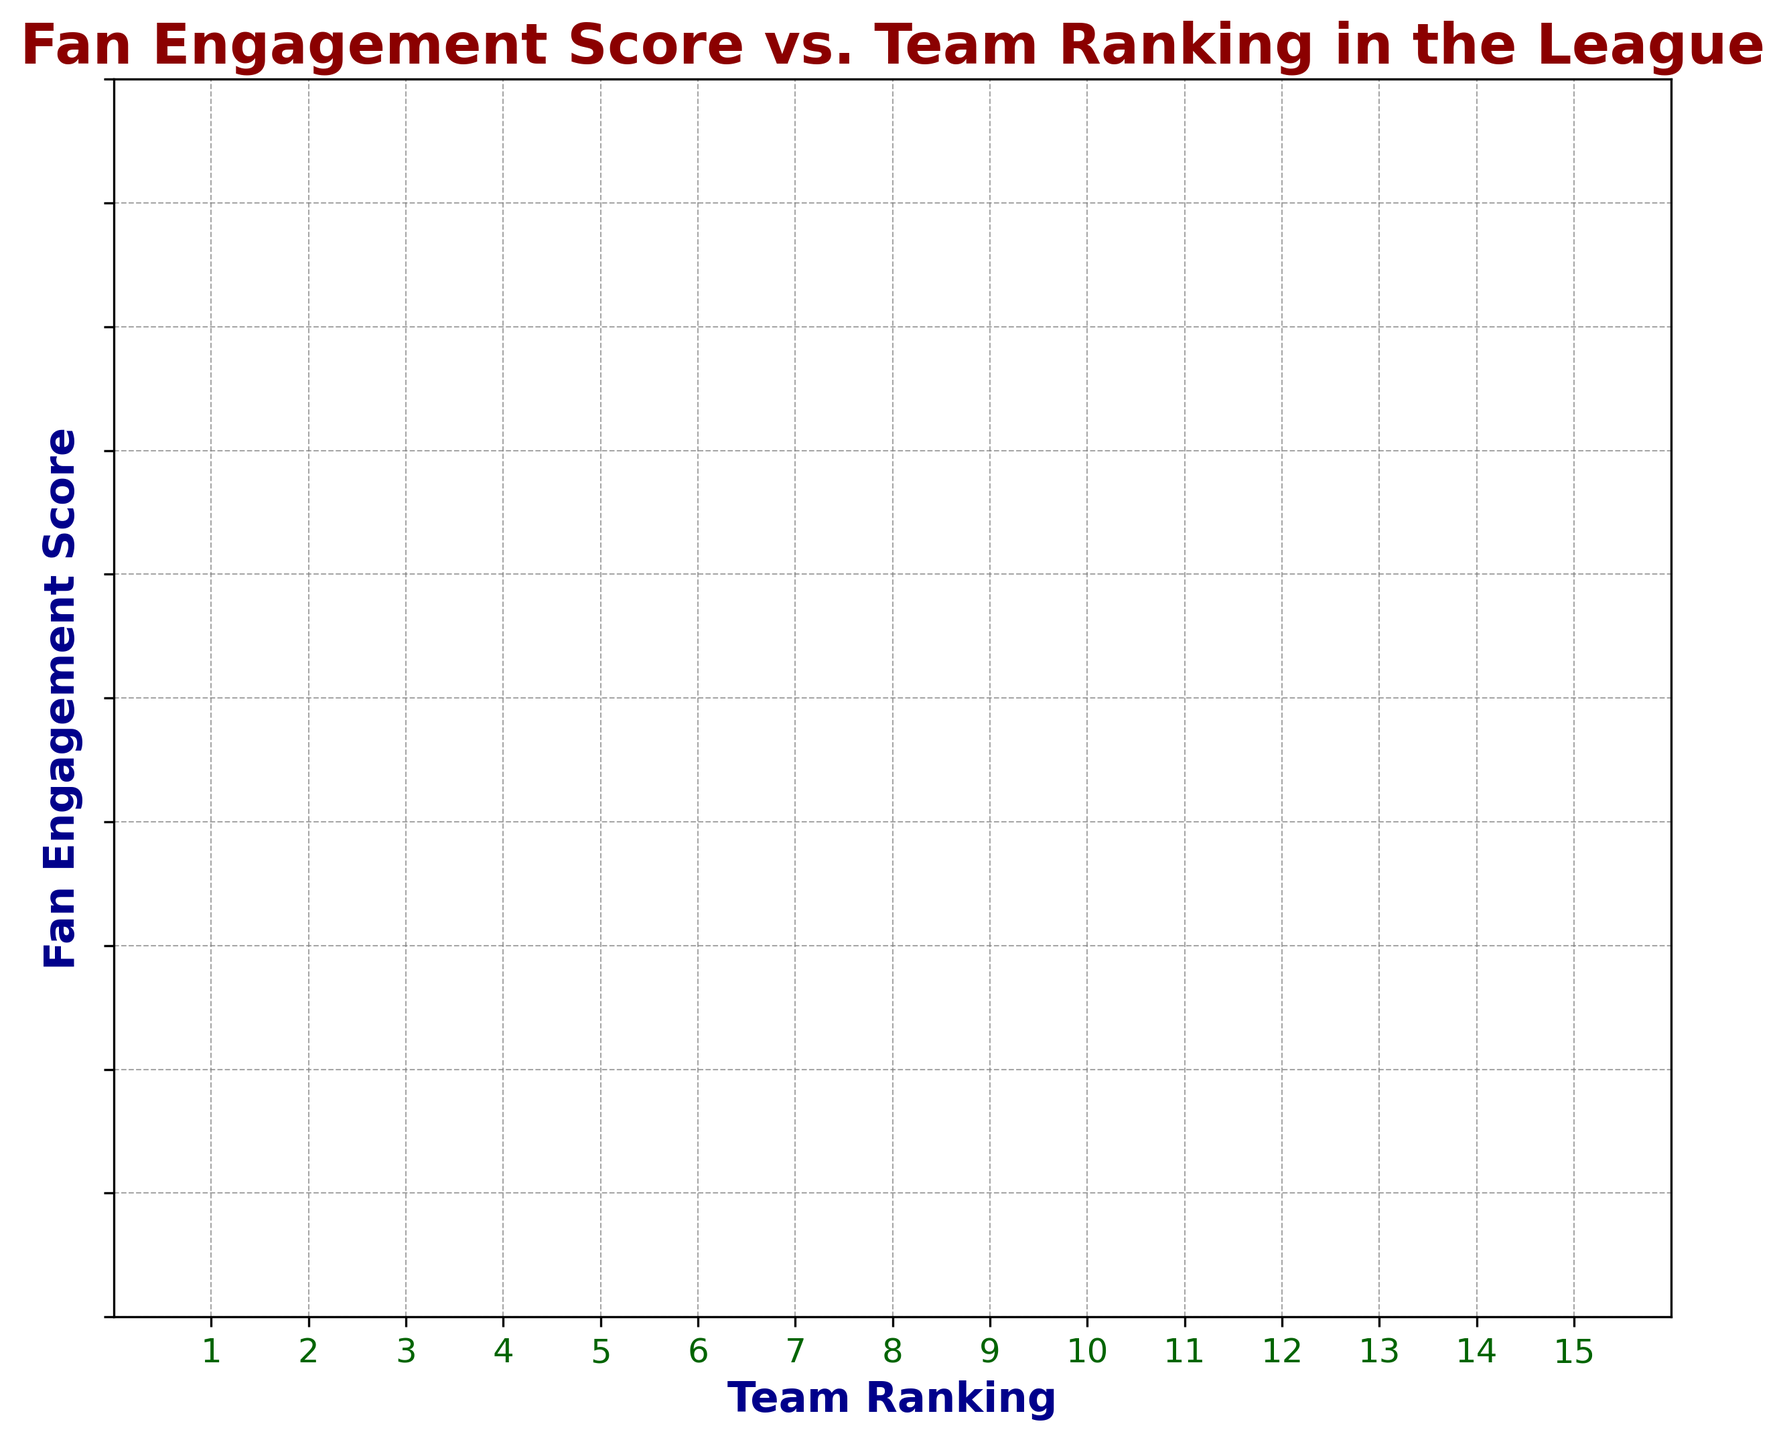What's the highest Fan Engagement Score achieved by a team? Look at the y-axis (Fan Engagement Score) and find the highest point on the scatter plot, which corresponds to the highest score.
Answer: 90 What's the Team Ranking of the team with a Fan Engagement Score of 77? Find the point on the scatter plot where the y-axis value (Fan Engagement Score) is 77. Then, check the corresponding x-axis value (Team Ranking).
Answer: 7 Which team has a higher Fan Engagement Score, the team ranked 3rd or the team ranked 5th? Locate the points for the 3rd and 5th ranked teams on the x-axis, then check the y-axis values for Fan Engagement Scores.
Answer: 3rd What's the difference in Fan Engagement Scores between the highest and lowest ranked teams? Find the Fan Engagement Scores for the highest (ranking 1) and lowest (ranking 15) ranked teams, then subtract the lower score from the higher score.
Answer: 27 Which Team Ranking has the lowest Fan Engagement Score? Look at the scatter plot and find the point with the lowest y-axis value (Fan Engagement Score), then note the corresponding x-axis value (Team Ranking).
Answer: 11 What is the average Fan Engagement Score of the top 3 ranked teams? Find the Fan Engagement Scores for the top 3 teams (ranked 1, 2, 3), sum them up, and then divide by 3: (75 + 68 + 82) / 3 = 75
Answer: 75 Is there a positive or negative trend between Fan Engagement Scores and Team Rankings? Observe the overall direction in which the points on the scatter plot move as the Team Ranking increases. A general downward trend would indicate a negative relationship.
Answer: Negative What's the combined Fan Engagement Score for the teams ranked 6th and 9th? Find the Fan Engagement Scores for the 6th and 9th ranked teams, then add the two values together: 85 (6th) + 80 (9th) = 165
Answer: 165 How many teams have a Fan Engagement Score above 80? Count the number of points on the scatter plot that lie above the y-axis value of 80.
Answer: 6 Do more teams have a Fan Engagement Score in the range of 60-70 or 80-90? Count the number of points that fall within each range on the y-axis.
Answer: 80-90 